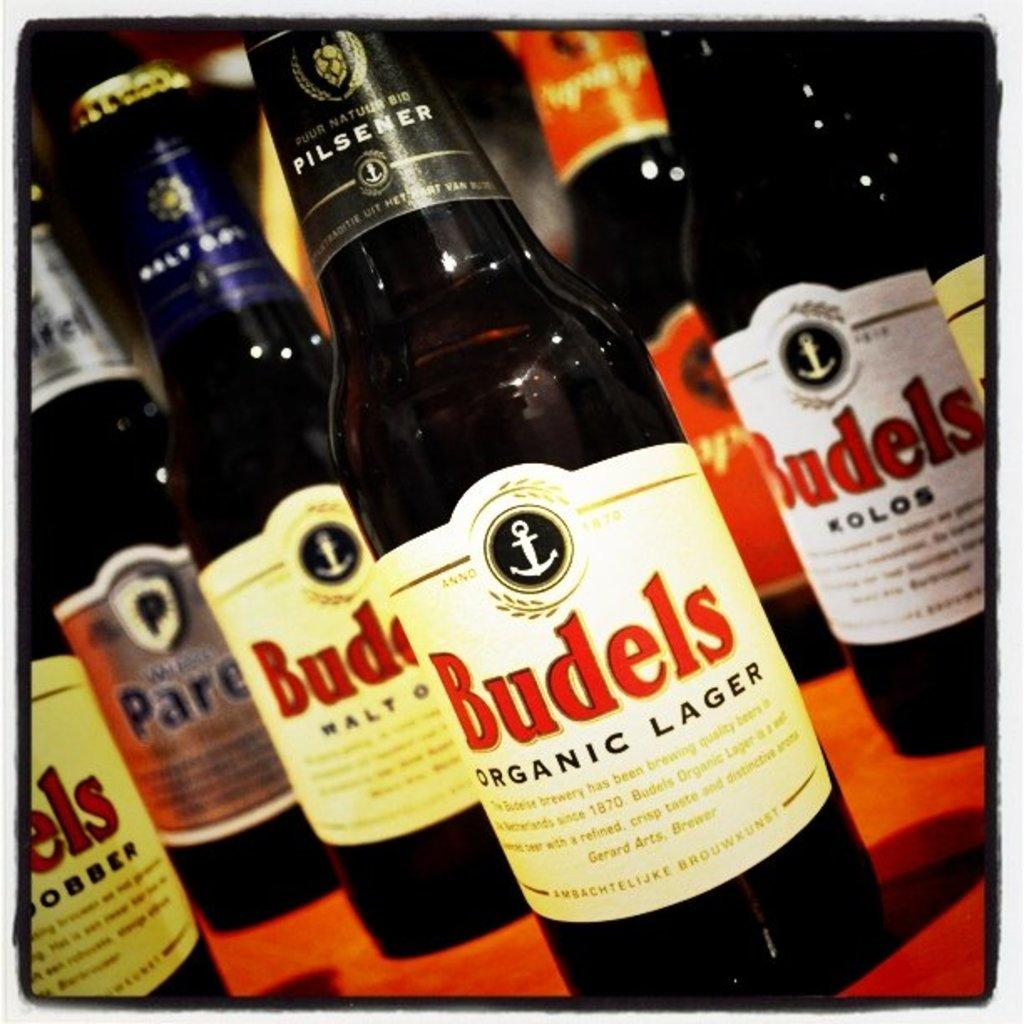<image>
Offer a succinct explanation of the picture presented. A bottle of Budels lager has a little anchor icon on the label. 